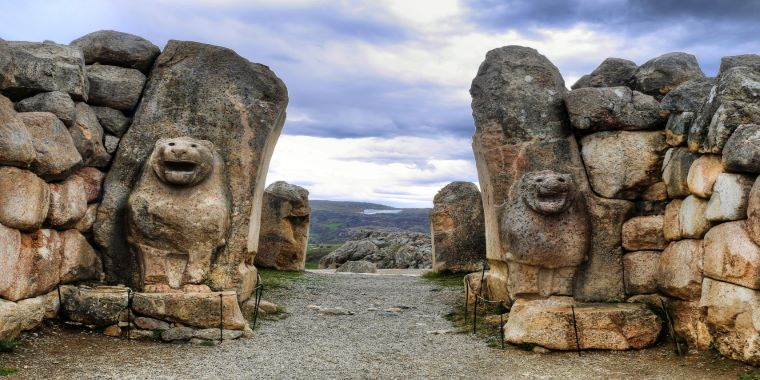If these lions could speak, what stories would they tell? The ancient lion guardians, weathered yet stoic, would recount tales spanning millennia. They would speak of the city's zenith under the Hittite kings, brimming with life and trade. Stories of monumental events would unravel—coronations, invasions, religious ceremonies, and daily bustling activities. They would whisper secrets of the city's fall and the silence that followed, enveloping the ruins in a cloak of mystery. Their stone eyes have witnessed the ebb and flow of time, and they've silently chronicled the passage of countless generations, each leaving an indelible mark on Hattusa's legacy. 